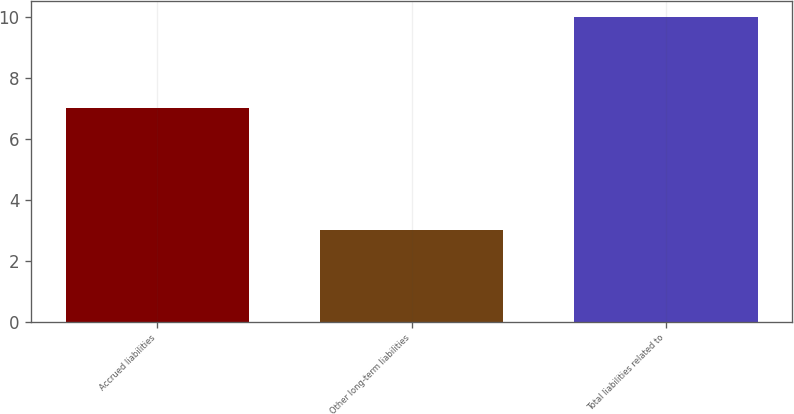Convert chart to OTSL. <chart><loc_0><loc_0><loc_500><loc_500><bar_chart><fcel>Accrued liabilities<fcel>Other long-term liabilities<fcel>Total liabilities related to<nl><fcel>7<fcel>3<fcel>10<nl></chart> 